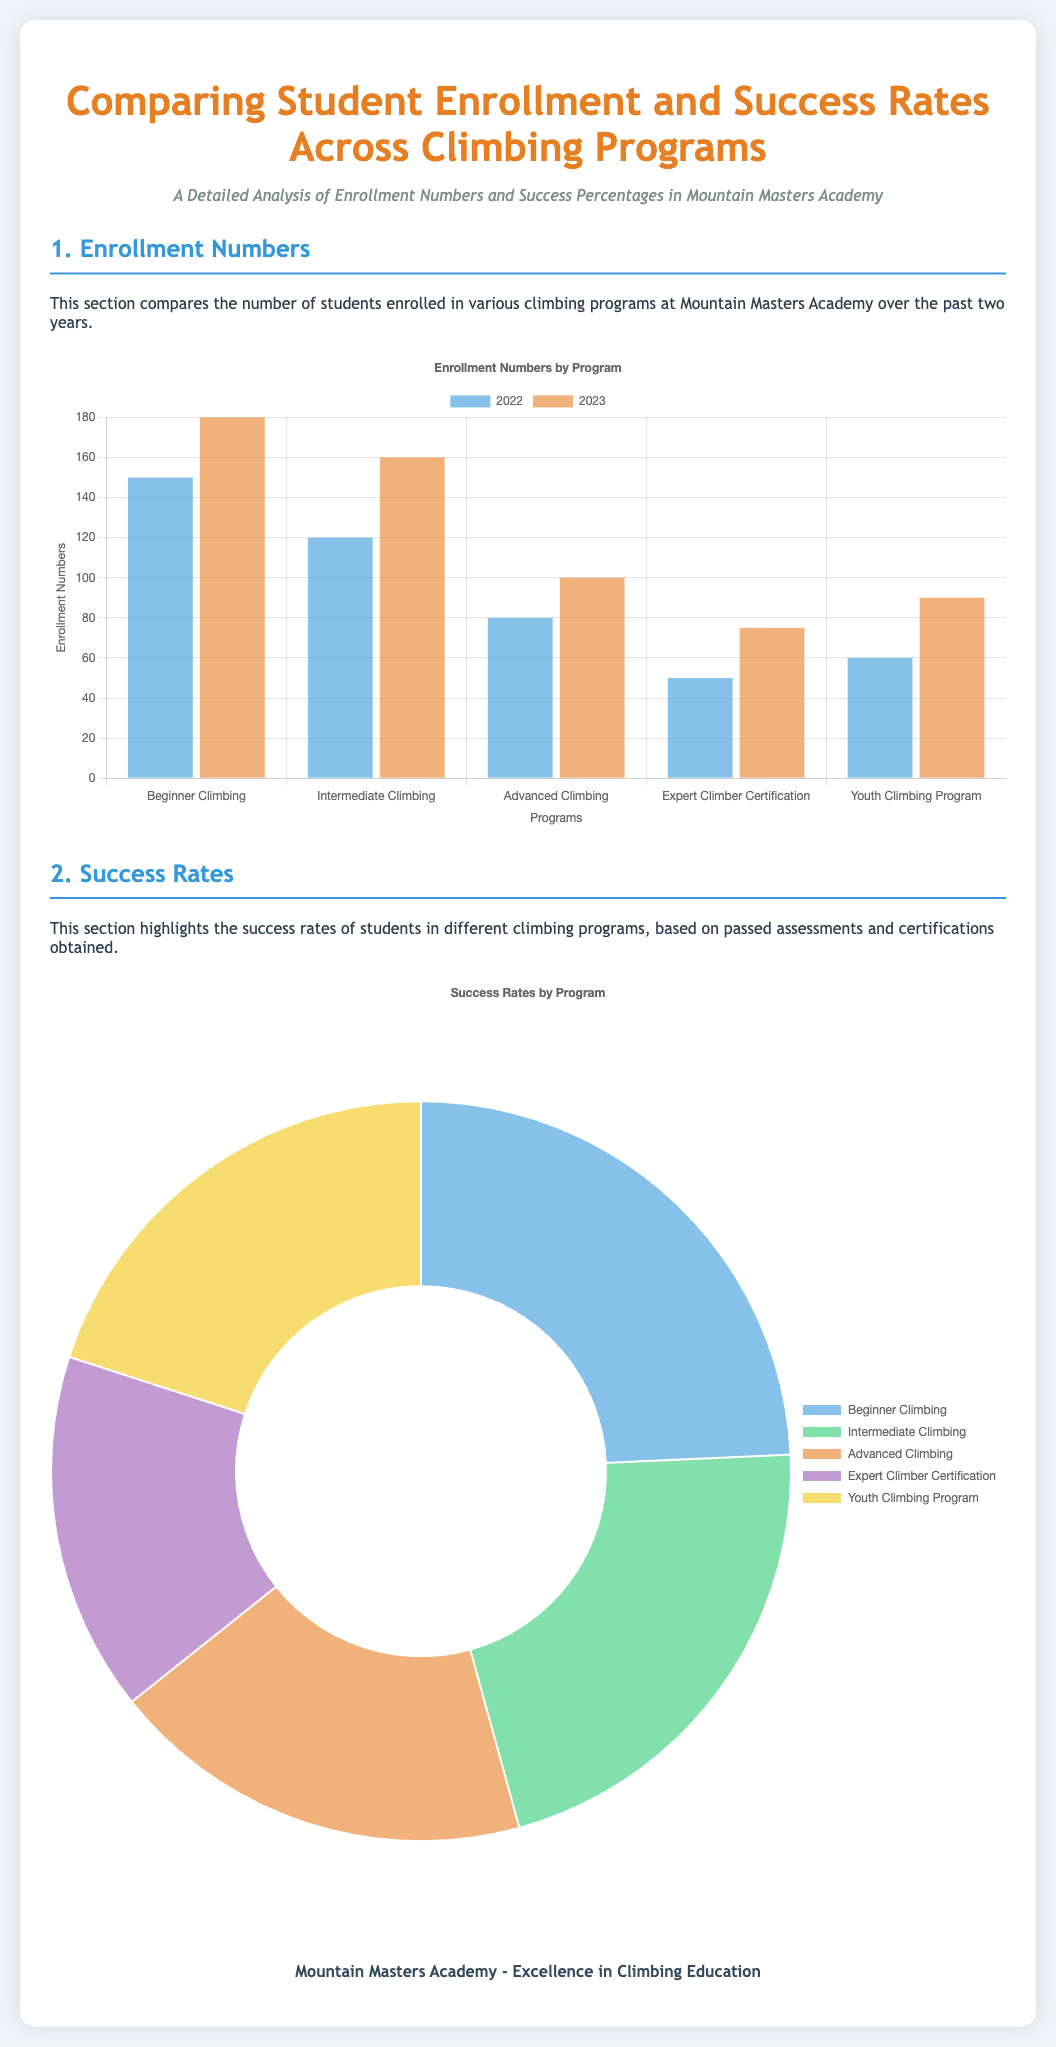What were the enrollment numbers for Beginner Climbing in 2023? The enrollment numbers for Beginner Climbing in 2023 is stated in the chart as 180.
Answer: 180 Which program had the highest success rate? The program with the highest success rate is indicated in the doughnut chart, which is Beginner Climbing at 85%.
Answer: Beginner Climbing How many students were enrolled in Advanced Climbing in 2022? The number of students enrolled in Advanced Climbing in 2022 is shown in the bar graph as 80.
Answer: 80 What is the success rate for the Expert Climber Certification program? The success rate for the Expert Climber Certification program can be found in the doughnut chart, which shows it as 55%.
Answer: 55% What was the enrollment increase for the Youth Climbing Program from 2022 to 2023? The increase in enrollment for the Youth Climbing Program can be calculated by subtracting the 2022 number (60) from the 2023 number (90), resulting in an increase of 30.
Answer: 30 Which type of chart is used for success rates? The type of chart used for success rates is a doughnut chart, as indicated in the section description.
Answer: Doughnut chart How many students were enrolled in Intermediate Climbing in 2022? The enrollment number for Intermediate Climbing in 2022 is displayed in the graph as 120.
Answer: 120 What percentage of students in Advanced Climbing succeeded? The success percentage for Advanced Climbing is shown in the doughnut chart as 65%.
Answer: 65% What was the overall trend in enrollment from 2022 to 2023? The overall trend in enrollment from 2022 to 2023 can be deduced from the bar graph showing an increase in most programs.
Answer: Increase 